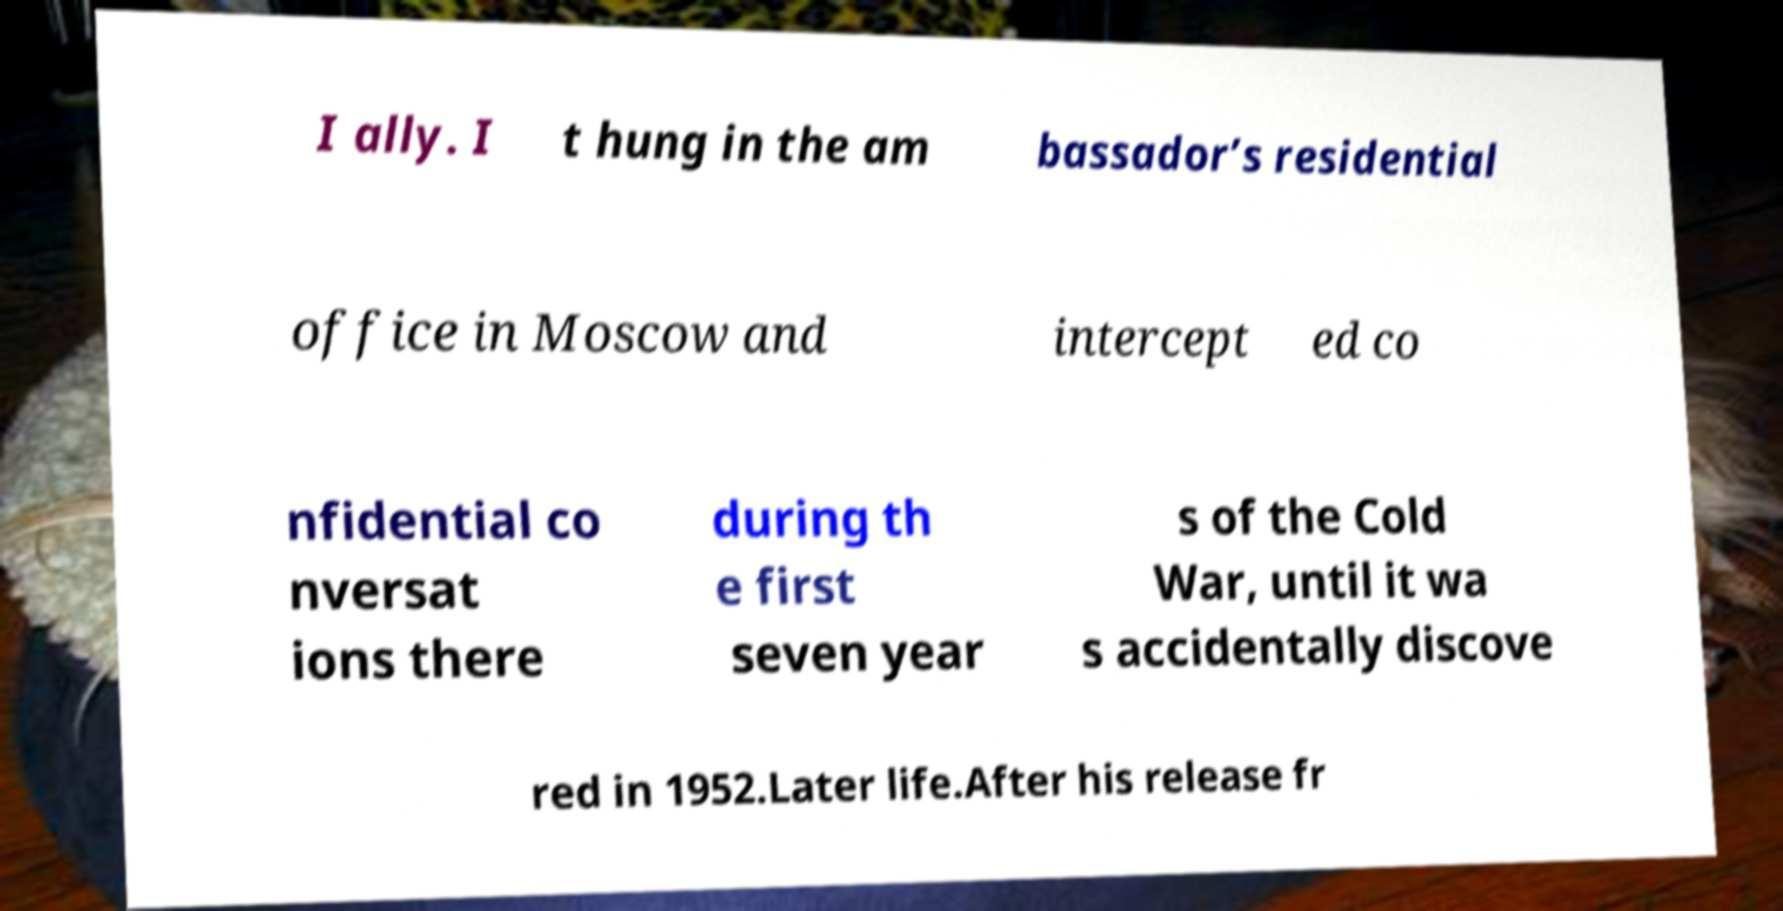For documentation purposes, I need the text within this image transcribed. Could you provide that? I ally. I t hung in the am bassador’s residential office in Moscow and intercept ed co nfidential co nversat ions there during th e first seven year s of the Cold War, until it wa s accidentally discove red in 1952.Later life.After his release fr 